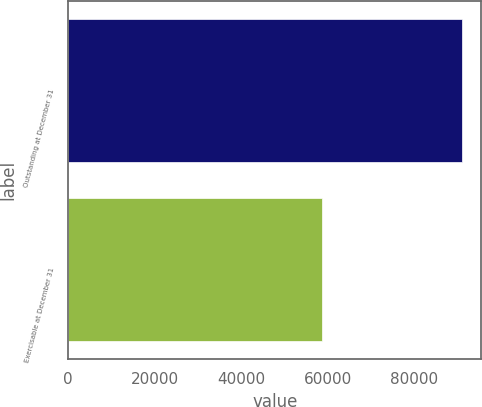Convert chart. <chart><loc_0><loc_0><loc_500><loc_500><bar_chart><fcel>Outstanding at December 31<fcel>Exercisable at December 31<nl><fcel>91075<fcel>58708<nl></chart> 